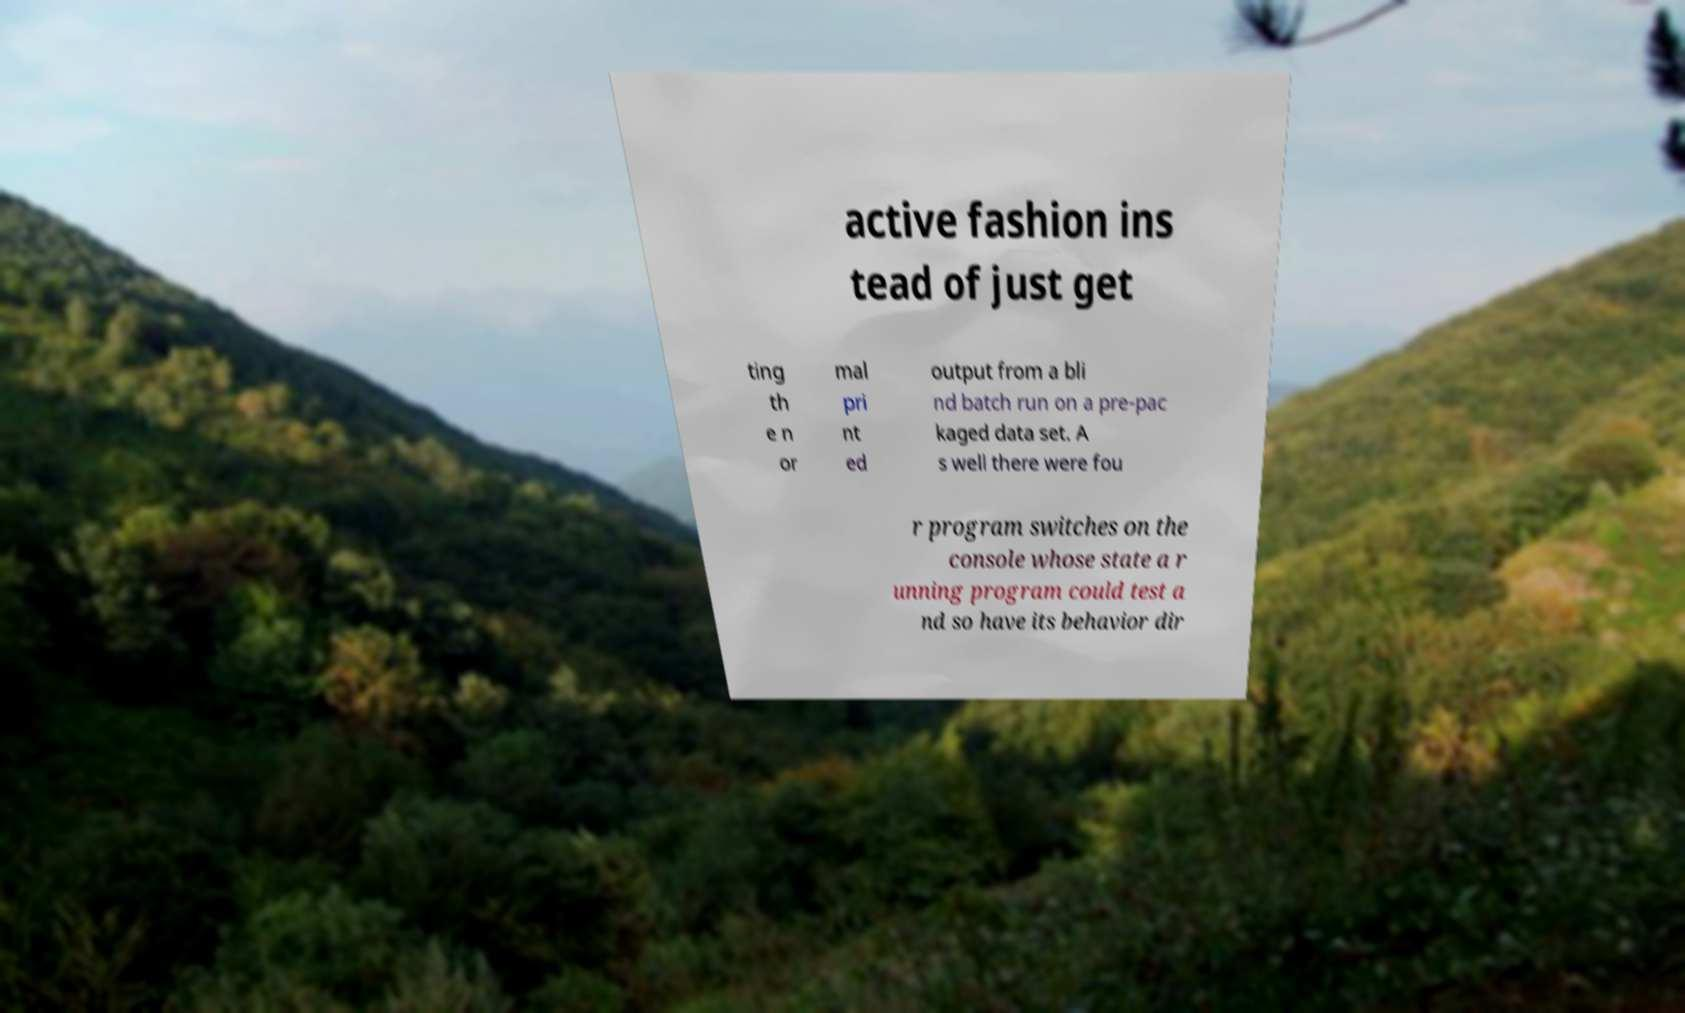I need the written content from this picture converted into text. Can you do that? active fashion ins tead of just get ting th e n or mal pri nt ed output from a bli nd batch run on a pre-pac kaged data set. A s well there were fou r program switches on the console whose state a r unning program could test a nd so have its behavior dir 